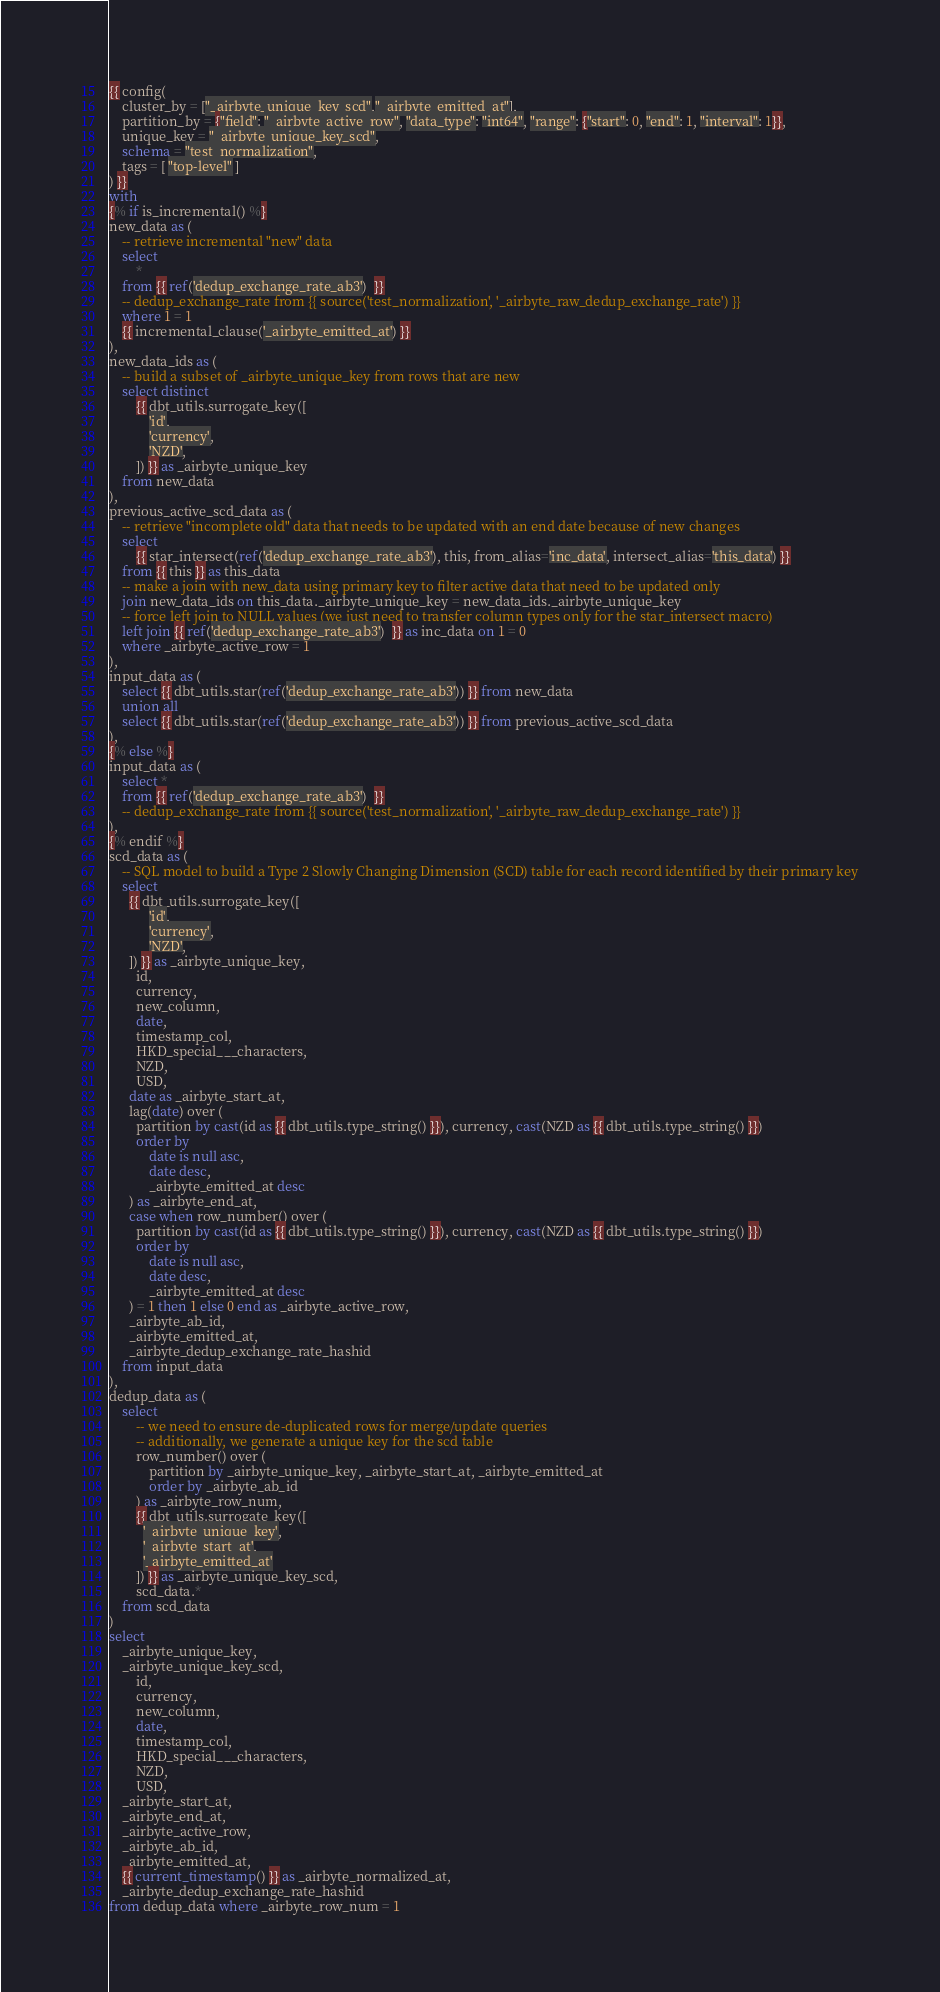Convert code to text. <code><loc_0><loc_0><loc_500><loc_500><_SQL_>{{ config(
    cluster_by = ["_airbyte_unique_key_scd","_airbyte_emitted_at"],
    partition_by = {"field": "_airbyte_active_row", "data_type": "int64", "range": {"start": 0, "end": 1, "interval": 1}},
    unique_key = "_airbyte_unique_key_scd",
    schema = "test_normalization",
    tags = [ "top-level" ]
) }}
with
{% if is_incremental() %}
new_data as (
    -- retrieve incremental "new" data
    select
        *
    from {{ ref('dedup_exchange_rate_ab3')  }}
    -- dedup_exchange_rate from {{ source('test_normalization', '_airbyte_raw_dedup_exchange_rate') }}
    where 1 = 1
    {{ incremental_clause('_airbyte_emitted_at') }}
),
new_data_ids as (
    -- build a subset of _airbyte_unique_key from rows that are new
    select distinct
        {{ dbt_utils.surrogate_key([
            'id',
            'currency',
            'NZD',
        ]) }} as _airbyte_unique_key
    from new_data
),
previous_active_scd_data as (
    -- retrieve "incomplete old" data that needs to be updated with an end date because of new changes
    select
        {{ star_intersect(ref('dedup_exchange_rate_ab3'), this, from_alias='inc_data', intersect_alias='this_data') }}
    from {{ this }} as this_data
    -- make a join with new_data using primary key to filter active data that need to be updated only
    join new_data_ids on this_data._airbyte_unique_key = new_data_ids._airbyte_unique_key
    -- force left join to NULL values (we just need to transfer column types only for the star_intersect macro)
    left join {{ ref('dedup_exchange_rate_ab3')  }} as inc_data on 1 = 0
    where _airbyte_active_row = 1
),
input_data as (
    select {{ dbt_utils.star(ref('dedup_exchange_rate_ab3')) }} from new_data
    union all
    select {{ dbt_utils.star(ref('dedup_exchange_rate_ab3')) }} from previous_active_scd_data
),
{% else %}
input_data as (
    select *
    from {{ ref('dedup_exchange_rate_ab3')  }}
    -- dedup_exchange_rate from {{ source('test_normalization', '_airbyte_raw_dedup_exchange_rate') }}
),
{% endif %}
scd_data as (
    -- SQL model to build a Type 2 Slowly Changing Dimension (SCD) table for each record identified by their primary key
    select
      {{ dbt_utils.surrogate_key([
            'id',
            'currency',
            'NZD',
      ]) }} as _airbyte_unique_key,
        id,
        currency,
        new_column,
        date,
        timestamp_col,
        HKD_special___characters,
        NZD,
        USD,
      date as _airbyte_start_at,
      lag(date) over (
        partition by cast(id as {{ dbt_utils.type_string() }}), currency, cast(NZD as {{ dbt_utils.type_string() }})
        order by
            date is null asc,
            date desc,
            _airbyte_emitted_at desc
      ) as _airbyte_end_at,
      case when row_number() over (
        partition by cast(id as {{ dbt_utils.type_string() }}), currency, cast(NZD as {{ dbt_utils.type_string() }})
        order by
            date is null asc,
            date desc,
            _airbyte_emitted_at desc
      ) = 1 then 1 else 0 end as _airbyte_active_row,
      _airbyte_ab_id,
      _airbyte_emitted_at,
      _airbyte_dedup_exchange_rate_hashid
    from input_data
),
dedup_data as (
    select
        -- we need to ensure de-duplicated rows for merge/update queries
        -- additionally, we generate a unique key for the scd table
        row_number() over (
            partition by _airbyte_unique_key, _airbyte_start_at, _airbyte_emitted_at
            order by _airbyte_ab_id
        ) as _airbyte_row_num,
        {{ dbt_utils.surrogate_key([
          '_airbyte_unique_key',
          '_airbyte_start_at',
          '_airbyte_emitted_at'
        ]) }} as _airbyte_unique_key_scd,
        scd_data.*
    from scd_data
)
select
    _airbyte_unique_key,
    _airbyte_unique_key_scd,
        id,
        currency,
        new_column,
        date,
        timestamp_col,
        HKD_special___characters,
        NZD,
        USD,
    _airbyte_start_at,
    _airbyte_end_at,
    _airbyte_active_row,
    _airbyte_ab_id,
    _airbyte_emitted_at,
    {{ current_timestamp() }} as _airbyte_normalized_at,
    _airbyte_dedup_exchange_rate_hashid
from dedup_data where _airbyte_row_num = 1

</code> 